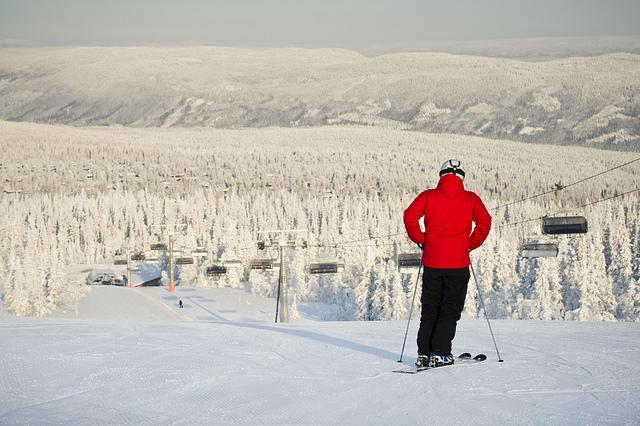What type of sport is he practicing? Please explain your reasoning. winter. The man is skiing on a snowy mountaintop. 